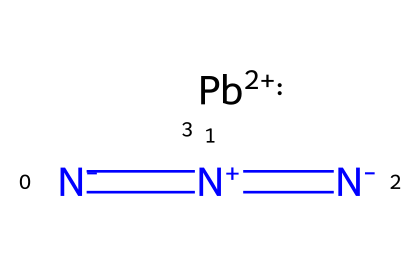What is the central metal atom in lead azide? The formula includes "Pb," which represents lead, indicating that lead is the central metal atom in the compound.
Answer: lead How many nitrogen atoms are present in lead azide? The structure shows three nitrogen atoms represented by "N," which confirms there are three nitrogen atoms in lead azide.
Answer: three What type of bond is present between the nitrogen atoms? The structure features multiple "=" signs between the nitrogen atoms, indicating that there are multiple double bonds (triple bond formation).
Answer: triple bond What charge does the lead ion carry in lead azide? The notation "[Pb+2]" indicates that the lead ion has a +2 charge.
Answer: +2 What type of compound is lead azide classified as? Since lead azide contains both azide ions and a metal, it is classified as an inorganic azide compound.
Answer: inorganic azide What does the presence of the azide functional group imply about lead azide's stability? The azide group is known for its instability and tendency to decompose, which affects the overall stability of lead azide.
Answer: unstable 